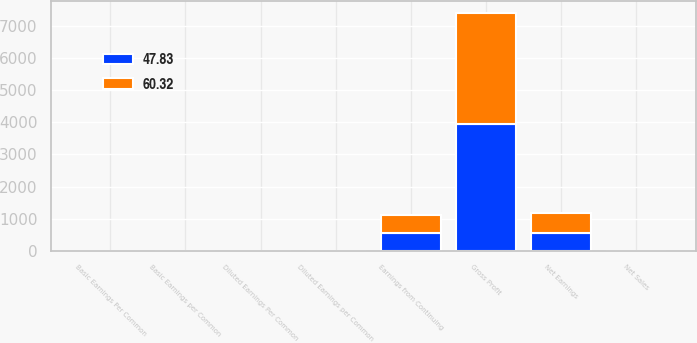Convert chart to OTSL. <chart><loc_0><loc_0><loc_500><loc_500><stacked_bar_chart><ecel><fcel>Net Sales<fcel>Gross Profit<fcel>Earnings from Continuing<fcel>Basic Earnings per Common<fcel>Diluted Earnings per Common<fcel>Net Earnings<fcel>Basic Earnings Per Common<fcel>Diluted Earnings Per Common<nl><fcel>47.83<fcel>0.34<fcel>3946<fcel>552<fcel>0.31<fcel>0.31<fcel>563<fcel>0.32<fcel>0.32<nl><fcel>60.32<fcel>0.34<fcel>3452<fcel>561<fcel>0.32<fcel>0.32<fcel>603<fcel>0.34<fcel>0.34<nl></chart> 